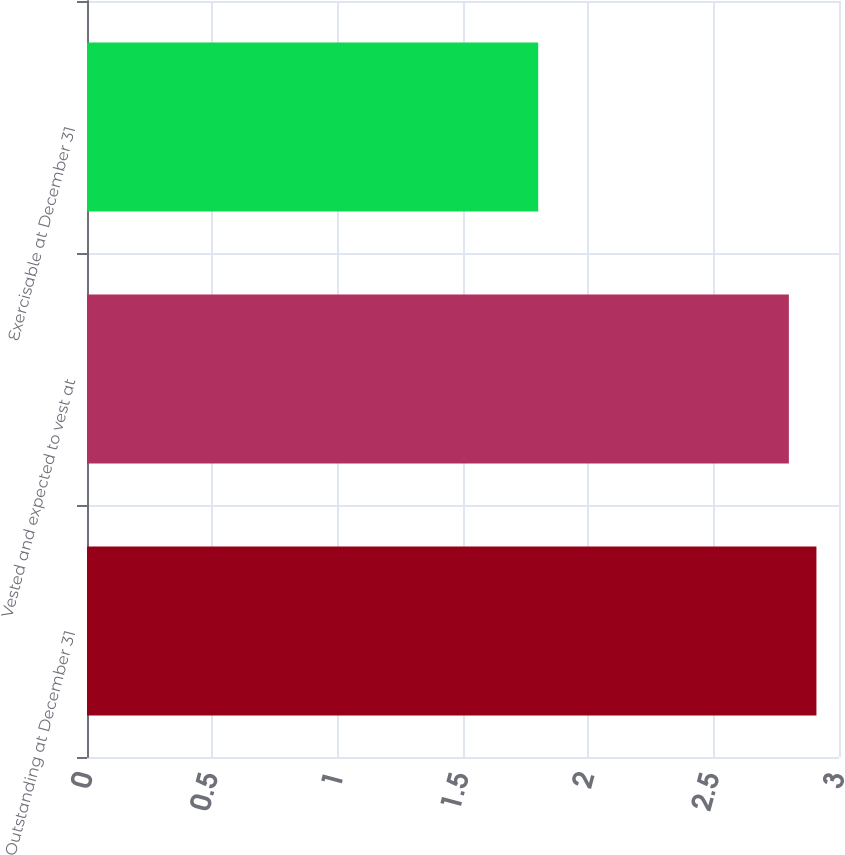<chart> <loc_0><loc_0><loc_500><loc_500><bar_chart><fcel>Outstanding at December 31<fcel>Vested and expected to vest at<fcel>Exercisable at December 31<nl><fcel>2.91<fcel>2.8<fcel>1.8<nl></chart> 